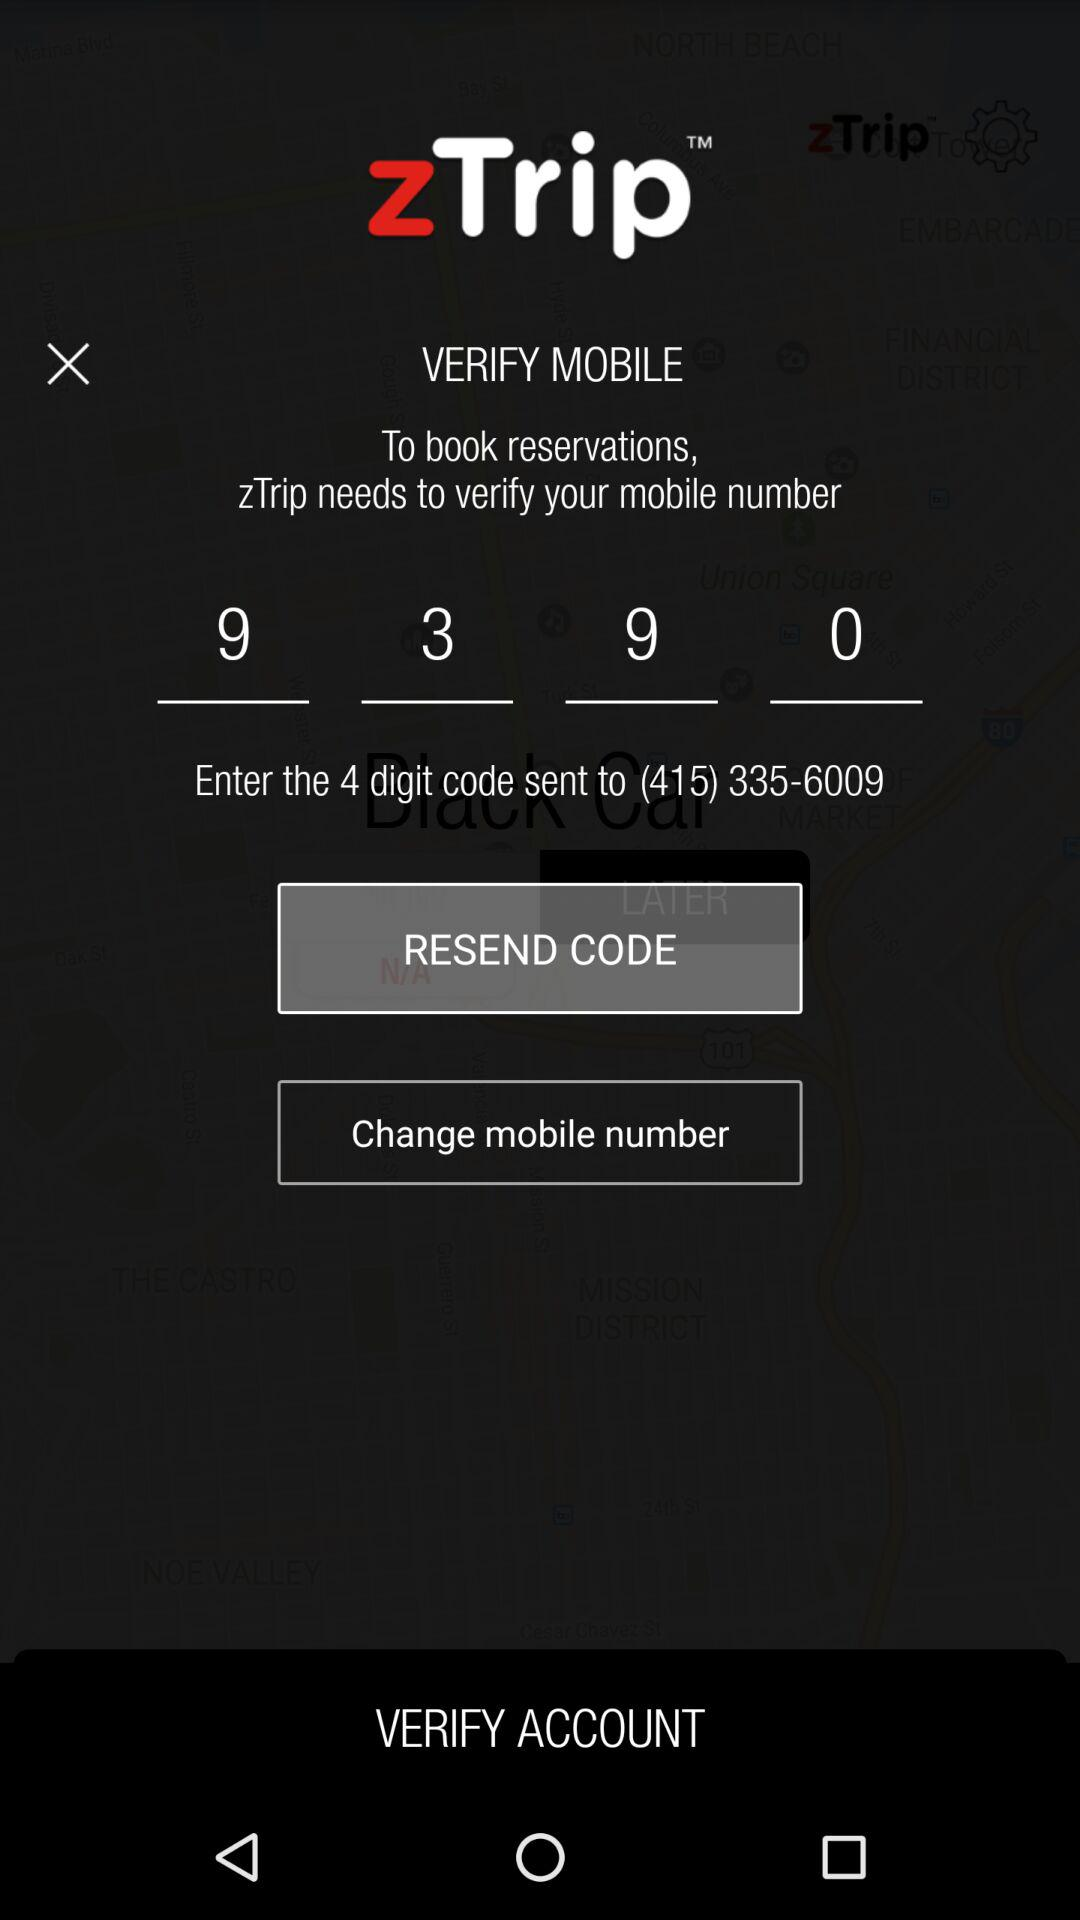What is the application name? The application name is "zTrip". 